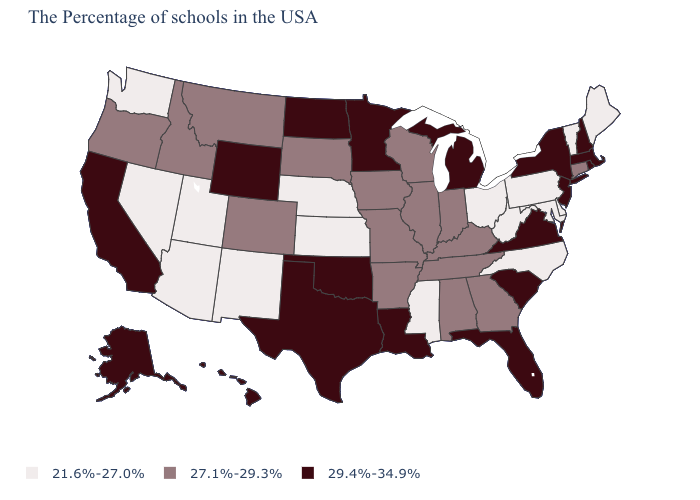Is the legend a continuous bar?
Quick response, please. No. Which states have the lowest value in the USA?
Write a very short answer. Maine, Vermont, Delaware, Maryland, Pennsylvania, North Carolina, West Virginia, Ohio, Mississippi, Kansas, Nebraska, New Mexico, Utah, Arizona, Nevada, Washington. What is the highest value in states that border Vermont?
Keep it brief. 29.4%-34.9%. Does Delaware have the lowest value in the USA?
Give a very brief answer. Yes. How many symbols are there in the legend?
Short answer required. 3. What is the value of Alabama?
Keep it brief. 27.1%-29.3%. Name the states that have a value in the range 29.4%-34.9%?
Keep it brief. Massachusetts, Rhode Island, New Hampshire, New York, New Jersey, Virginia, South Carolina, Florida, Michigan, Louisiana, Minnesota, Oklahoma, Texas, North Dakota, Wyoming, California, Alaska, Hawaii. Among the states that border Oregon , which have the lowest value?
Answer briefly. Nevada, Washington. What is the value of Vermont?
Give a very brief answer. 21.6%-27.0%. Name the states that have a value in the range 21.6%-27.0%?
Keep it brief. Maine, Vermont, Delaware, Maryland, Pennsylvania, North Carolina, West Virginia, Ohio, Mississippi, Kansas, Nebraska, New Mexico, Utah, Arizona, Nevada, Washington. What is the value of Kansas?
Quick response, please. 21.6%-27.0%. What is the value of Oregon?
Write a very short answer. 27.1%-29.3%. Does Nebraska have the highest value in the USA?
Keep it brief. No. What is the value of New Jersey?
Give a very brief answer. 29.4%-34.9%. What is the value of Alabama?
Quick response, please. 27.1%-29.3%. 